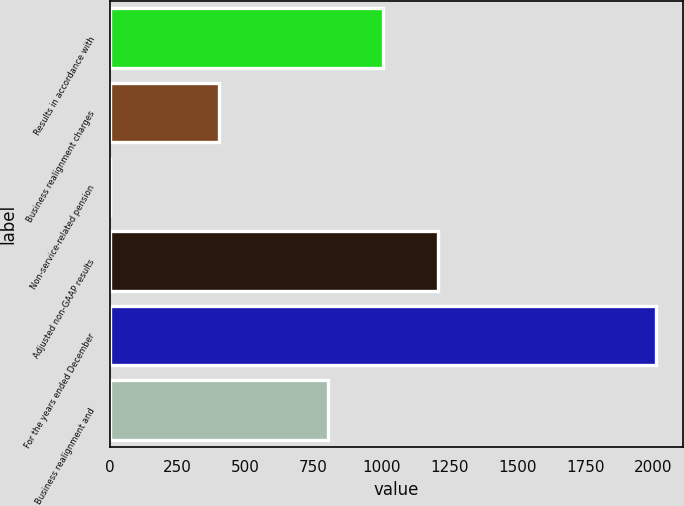Convert chart to OTSL. <chart><loc_0><loc_0><loc_500><loc_500><bar_chart><fcel>Results in accordance with<fcel>Business realignment charges<fcel>Non-service-related pension<fcel>Adjusted non-GAAP results<fcel>For the years ended December<fcel>Business realignment and<nl><fcel>1005.5<fcel>403.4<fcel>2<fcel>1206.2<fcel>2009<fcel>804.8<nl></chart> 